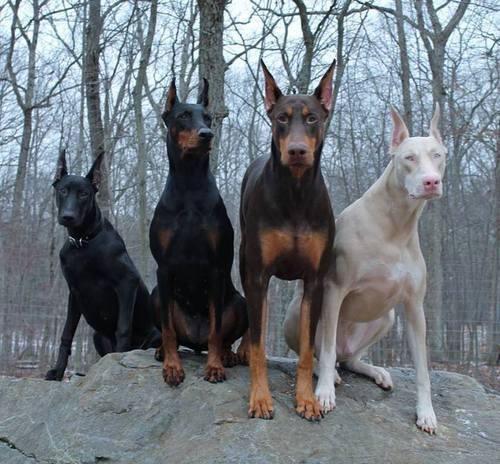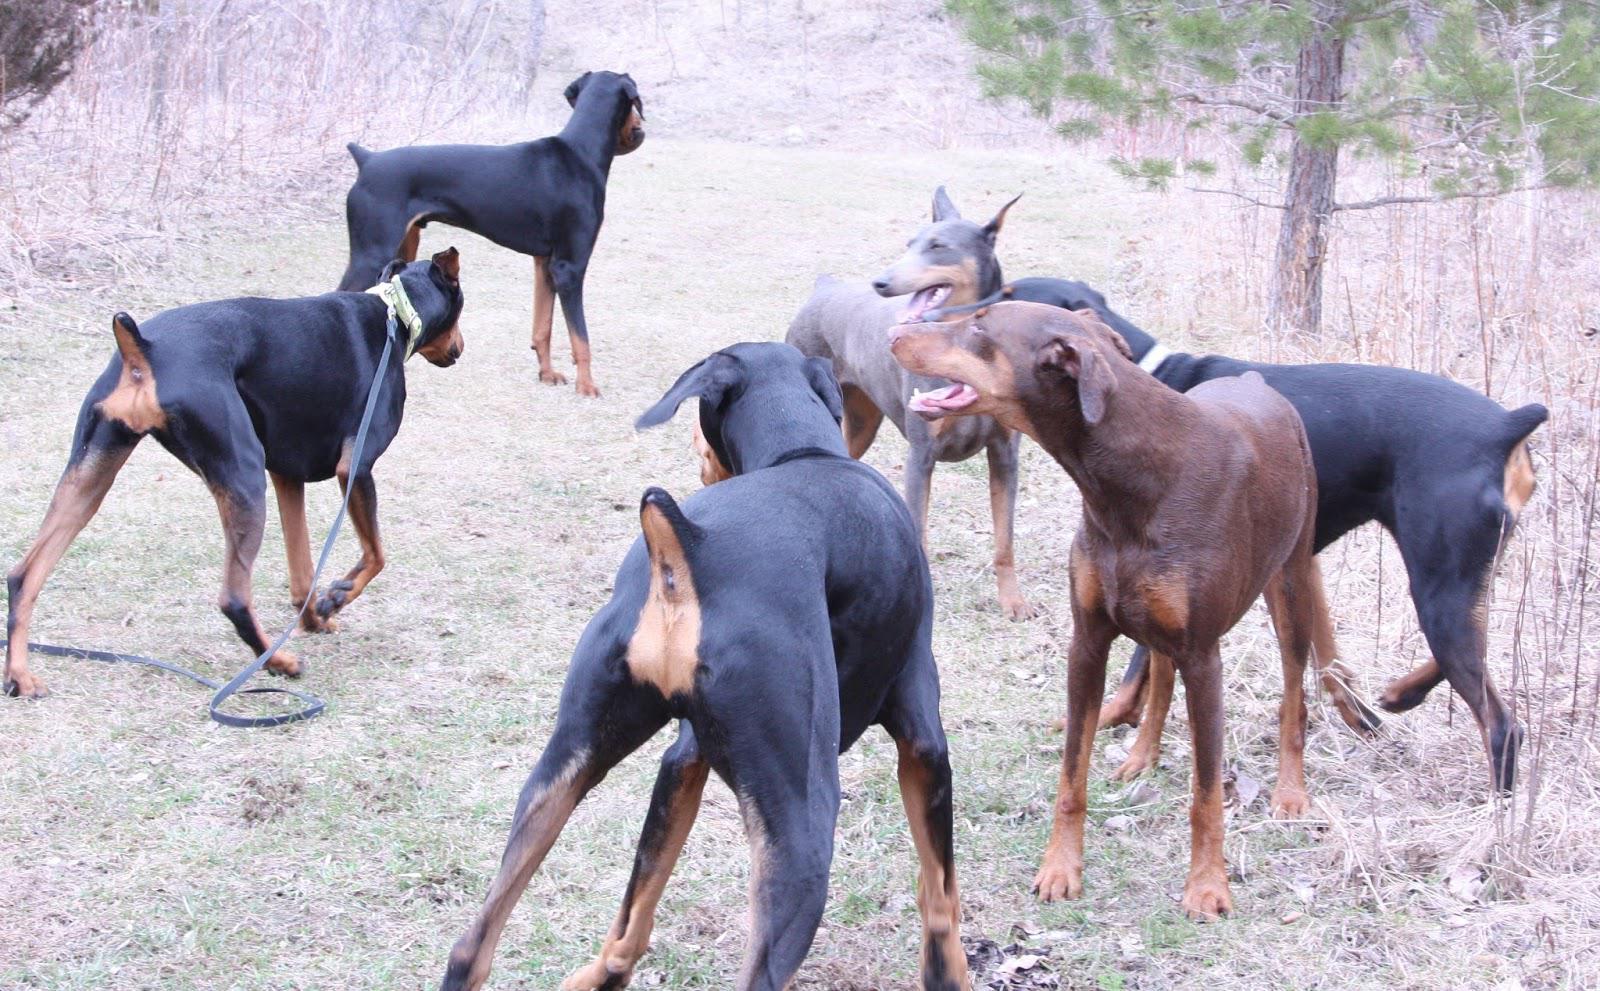The first image is the image on the left, the second image is the image on the right. Given the left and right images, does the statement "The right image contains exactly two dogs." hold true? Answer yes or no. No. 